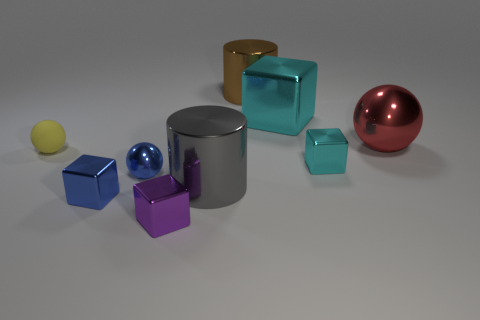Subtract all tiny yellow balls. How many balls are left? 2 Subtract all purple balls. How many cyan cubes are left? 2 Add 1 red blocks. How many objects exist? 10 Subtract all yellow spheres. How many spheres are left? 2 Add 2 big cyan metal cubes. How many big cyan metal cubes exist? 3 Subtract 0 green cylinders. How many objects are left? 9 Subtract all cylinders. How many objects are left? 7 Subtract all purple spheres. Subtract all cyan blocks. How many spheres are left? 3 Subtract all large gray metallic things. Subtract all tiny blue cubes. How many objects are left? 7 Add 9 big cyan cubes. How many big cyan cubes are left? 10 